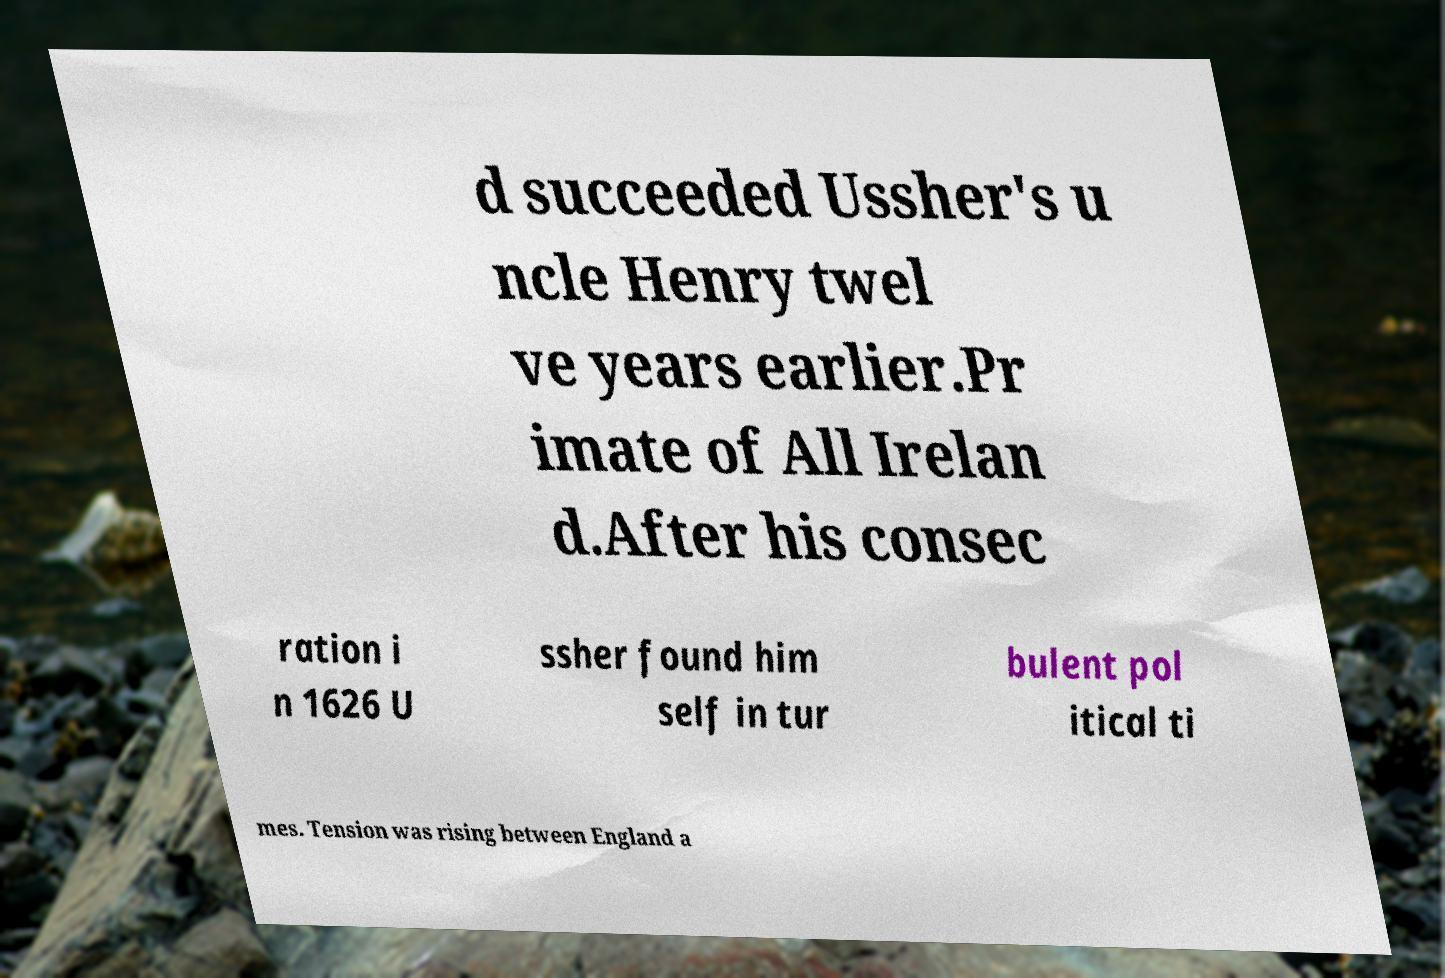What messages or text are displayed in this image? I need them in a readable, typed format. d succeeded Ussher's u ncle Henry twel ve years earlier.Pr imate of All Irelan d.After his consec ration i n 1626 U ssher found him self in tur bulent pol itical ti mes. Tension was rising between England a 